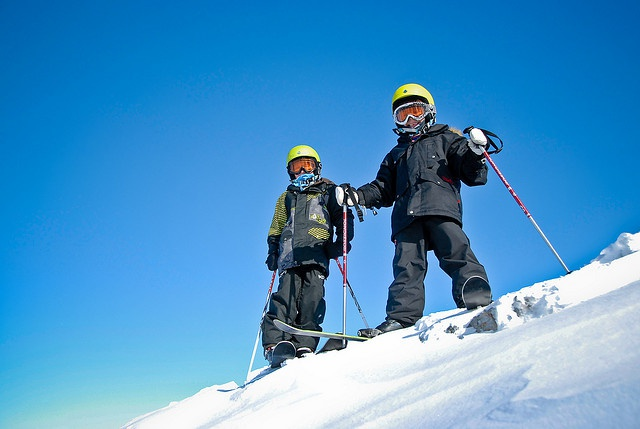Describe the objects in this image and their specific colors. I can see people in blue, black, gray, navy, and darkblue tones, people in blue, black, gray, and navy tones, skis in blue, black, gray, and darkgray tones, and skis in blue, black, gray, and darkblue tones in this image. 